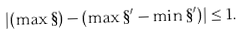Convert formula to latex. <formula><loc_0><loc_0><loc_500><loc_500>| ( \max \S ) - ( \max \S ^ { \prime } - \min \S ^ { \prime } ) | \leq 1 .</formula> 